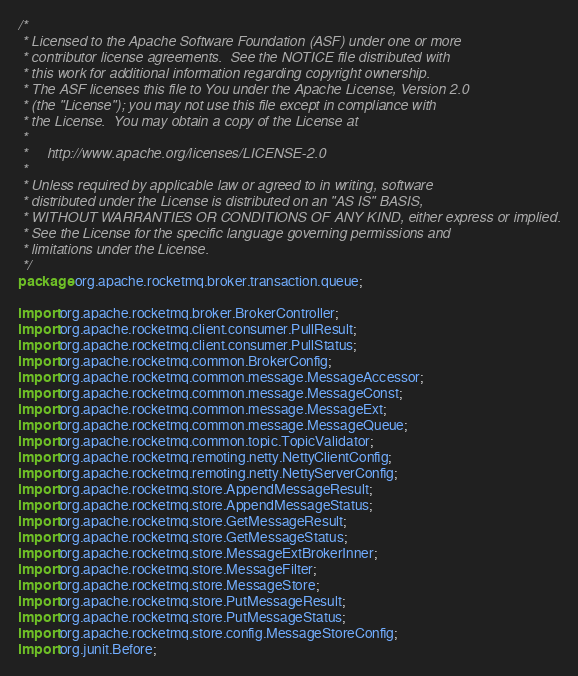<code> <loc_0><loc_0><loc_500><loc_500><_Java_>/*
 * Licensed to the Apache Software Foundation (ASF) under one or more
 * contributor license agreements.  See the NOTICE file distributed with
 * this work for additional information regarding copyright ownership.
 * The ASF licenses this file to You under the Apache License, Version 2.0
 * (the "License"); you may not use this file except in compliance with
 * the License.  You may obtain a copy of the License at
 *
 *     http://www.apache.org/licenses/LICENSE-2.0
 *
 * Unless required by applicable law or agreed to in writing, software
 * distributed under the License is distributed on an "AS IS" BASIS,
 * WITHOUT WARRANTIES OR CONDITIONS OF ANY KIND, either express or implied.
 * See the License for the specific language governing permissions and
 * limitations under the License.
 */
package org.apache.rocketmq.broker.transaction.queue;

import org.apache.rocketmq.broker.BrokerController;
import org.apache.rocketmq.client.consumer.PullResult;
import org.apache.rocketmq.client.consumer.PullStatus;
import org.apache.rocketmq.common.BrokerConfig;
import org.apache.rocketmq.common.message.MessageAccessor;
import org.apache.rocketmq.common.message.MessageConst;
import org.apache.rocketmq.common.message.MessageExt;
import org.apache.rocketmq.common.message.MessageQueue;
import org.apache.rocketmq.common.topic.TopicValidator;
import org.apache.rocketmq.remoting.netty.NettyClientConfig;
import org.apache.rocketmq.remoting.netty.NettyServerConfig;
import org.apache.rocketmq.store.AppendMessageResult;
import org.apache.rocketmq.store.AppendMessageStatus;
import org.apache.rocketmq.store.GetMessageResult;
import org.apache.rocketmq.store.GetMessageStatus;
import org.apache.rocketmq.store.MessageExtBrokerInner;
import org.apache.rocketmq.store.MessageFilter;
import org.apache.rocketmq.store.MessageStore;
import org.apache.rocketmq.store.PutMessageResult;
import org.apache.rocketmq.store.PutMessageStatus;
import org.apache.rocketmq.store.config.MessageStoreConfig;
import org.junit.Before;</code> 